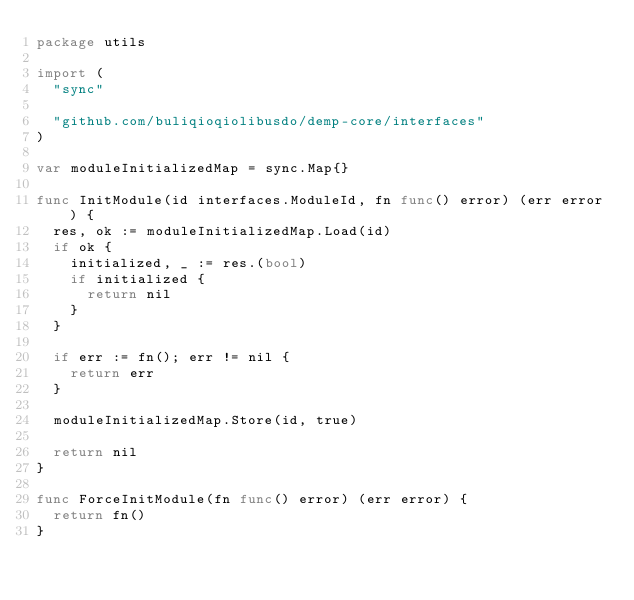<code> <loc_0><loc_0><loc_500><loc_500><_Go_>package utils

import (
	"sync"

	"github.com/buliqioqiolibusdo/demp-core/interfaces"
)

var moduleInitializedMap = sync.Map{}

func InitModule(id interfaces.ModuleId, fn func() error) (err error) {
	res, ok := moduleInitializedMap.Load(id)
	if ok {
		initialized, _ := res.(bool)
		if initialized {
			return nil
		}
	}

	if err := fn(); err != nil {
		return err
	}

	moduleInitializedMap.Store(id, true)

	return nil
}

func ForceInitModule(fn func() error) (err error) {
	return fn()
}
</code> 